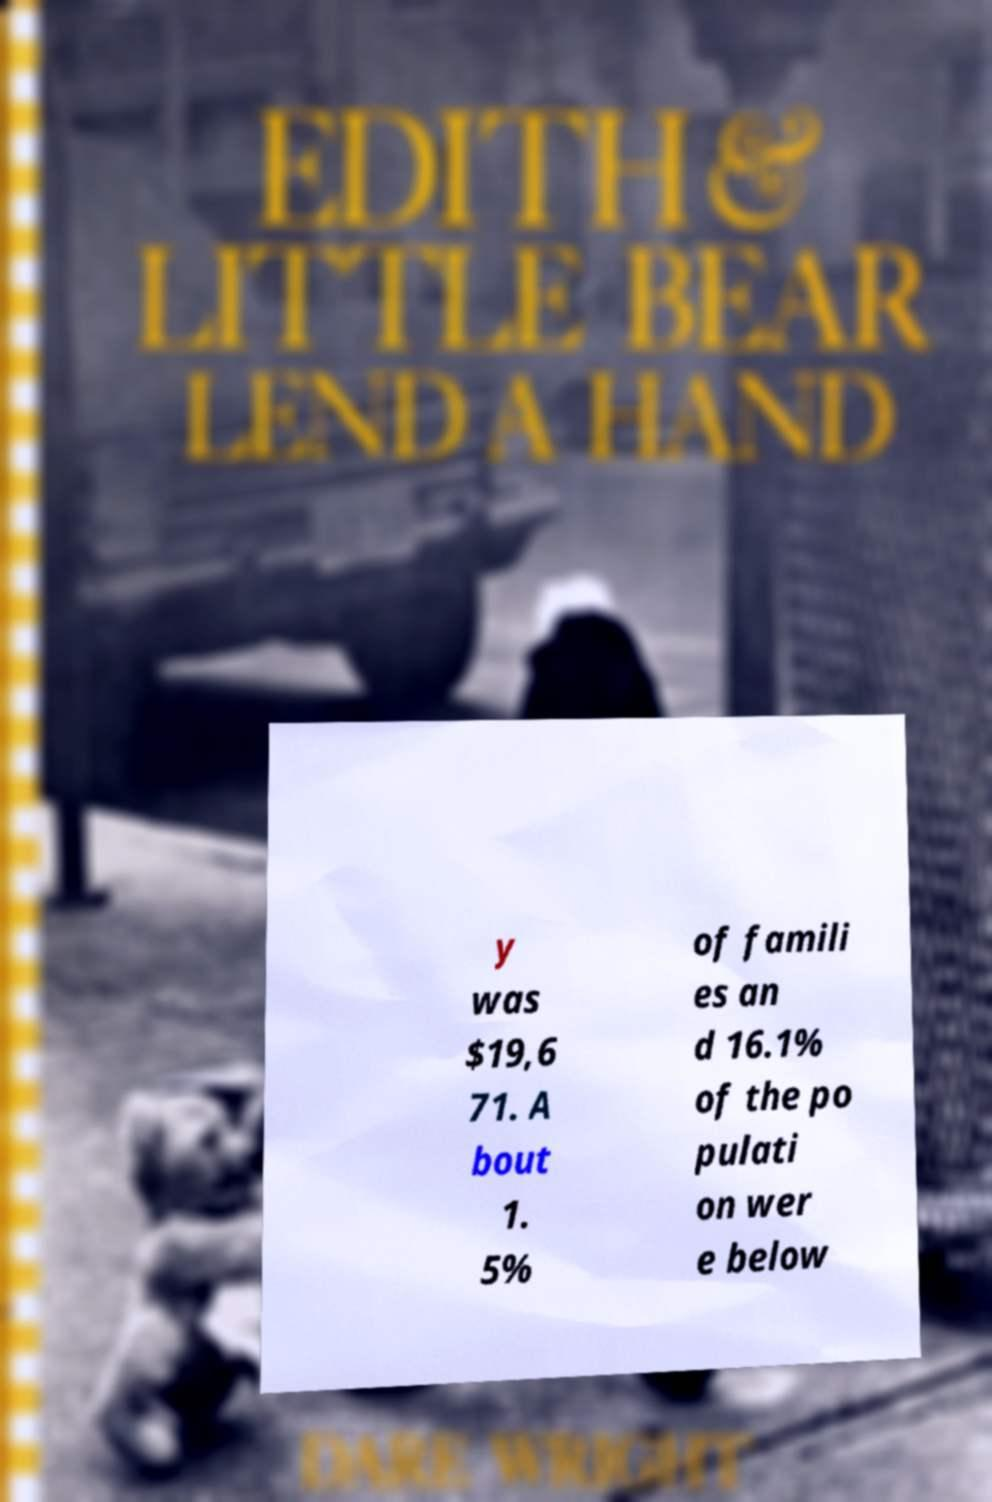There's text embedded in this image that I need extracted. Can you transcribe it verbatim? y was $19,6 71. A bout 1. 5% of famili es an d 16.1% of the po pulati on wer e below 